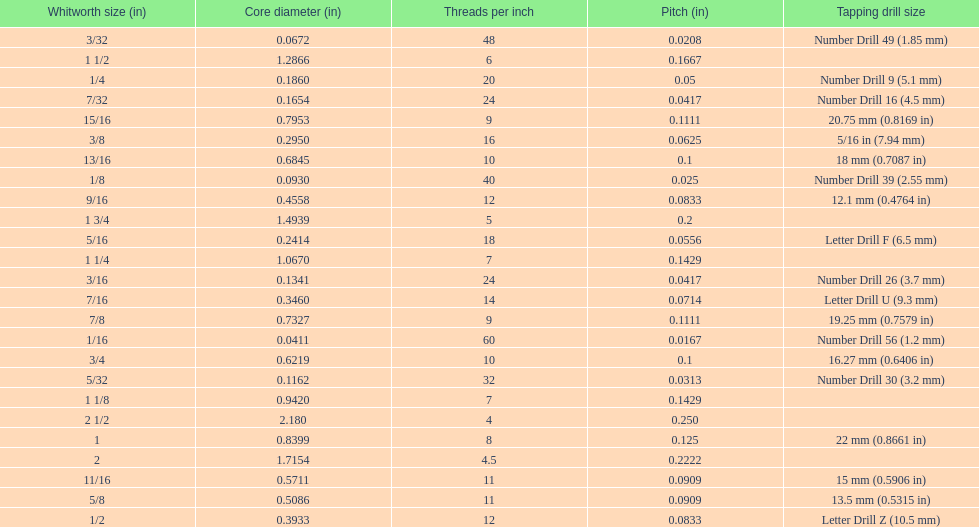Does any whitworth size have the same core diameter as the number drill 26? 3/16. Could you help me parse every detail presented in this table? {'header': ['Whitworth size (in)', 'Core diameter (in)', 'Threads per\xa0inch', 'Pitch (in)', 'Tapping drill size'], 'rows': [['3/32', '0.0672', '48', '0.0208', 'Number Drill 49 (1.85\xa0mm)'], ['1 1/2', '1.2866', '6', '0.1667', ''], ['1/4', '0.1860', '20', '0.05', 'Number Drill 9 (5.1\xa0mm)'], ['7/32', '0.1654', '24', '0.0417', 'Number Drill 16 (4.5\xa0mm)'], ['15/16', '0.7953', '9', '0.1111', '20.75\xa0mm (0.8169\xa0in)'], ['3/8', '0.2950', '16', '0.0625', '5/16\xa0in (7.94\xa0mm)'], ['13/16', '0.6845', '10', '0.1', '18\xa0mm (0.7087\xa0in)'], ['1/8', '0.0930', '40', '0.025', 'Number Drill 39 (2.55\xa0mm)'], ['9/16', '0.4558', '12', '0.0833', '12.1\xa0mm (0.4764\xa0in)'], ['1 3/4', '1.4939', '5', '0.2', ''], ['5/16', '0.2414', '18', '0.0556', 'Letter Drill F (6.5\xa0mm)'], ['1 1/4', '1.0670', '7', '0.1429', ''], ['3/16', '0.1341', '24', '0.0417', 'Number Drill 26 (3.7\xa0mm)'], ['7/16', '0.3460', '14', '0.0714', 'Letter Drill U (9.3\xa0mm)'], ['7/8', '0.7327', '9', '0.1111', '19.25\xa0mm (0.7579\xa0in)'], ['1/16', '0.0411', '60', '0.0167', 'Number Drill 56 (1.2\xa0mm)'], ['3/4', '0.6219', '10', '0.1', '16.27\xa0mm (0.6406\xa0in)'], ['5/32', '0.1162', '32', '0.0313', 'Number Drill 30 (3.2\xa0mm)'], ['1 1/8', '0.9420', '7', '0.1429', ''], ['2 1/2', '2.180', '4', '0.250', ''], ['1', '0.8399', '8', '0.125', '22\xa0mm (0.8661\xa0in)'], ['2', '1.7154', '4.5', '0.2222', ''], ['11/16', '0.5711', '11', '0.0909', '15\xa0mm (0.5906\xa0in)'], ['5/8', '0.5086', '11', '0.0909', '13.5\xa0mm (0.5315\xa0in)'], ['1/2', '0.3933', '12', '0.0833', 'Letter Drill Z (10.5\xa0mm)']]} 